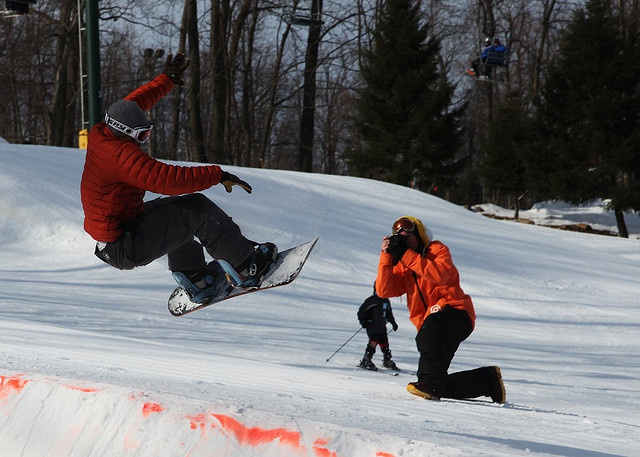Describe the objects in this image and their specific colors. I can see people in black, maroon, and darkgray tones, people in black, maroon, brown, and red tones, snowboard in black, darkgray, gray, and lightgray tones, people in black, gray, and darkgray tones, and people in black, navy, gray, and darkblue tones in this image. 